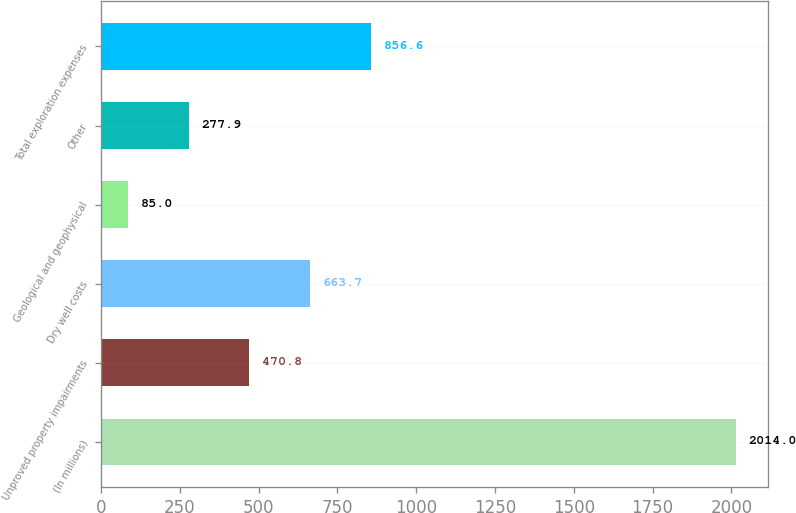Convert chart. <chart><loc_0><loc_0><loc_500><loc_500><bar_chart><fcel>(In millions)<fcel>Unproved property impairments<fcel>Dry well costs<fcel>Geological and geophysical<fcel>Other<fcel>Total exploration expenses<nl><fcel>2014<fcel>470.8<fcel>663.7<fcel>85<fcel>277.9<fcel>856.6<nl></chart> 